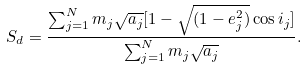<formula> <loc_0><loc_0><loc_500><loc_500>S _ { d } = \frac { \sum _ { j = 1 } ^ { N } m _ { j } \sqrt { a _ { j } } [ 1 - \sqrt { ( 1 - e _ { j } ^ { 2 } ) } \cos i _ { j } ] } { \sum _ { j = 1 } ^ { N } m _ { j } \sqrt { a _ { j } } } .</formula> 